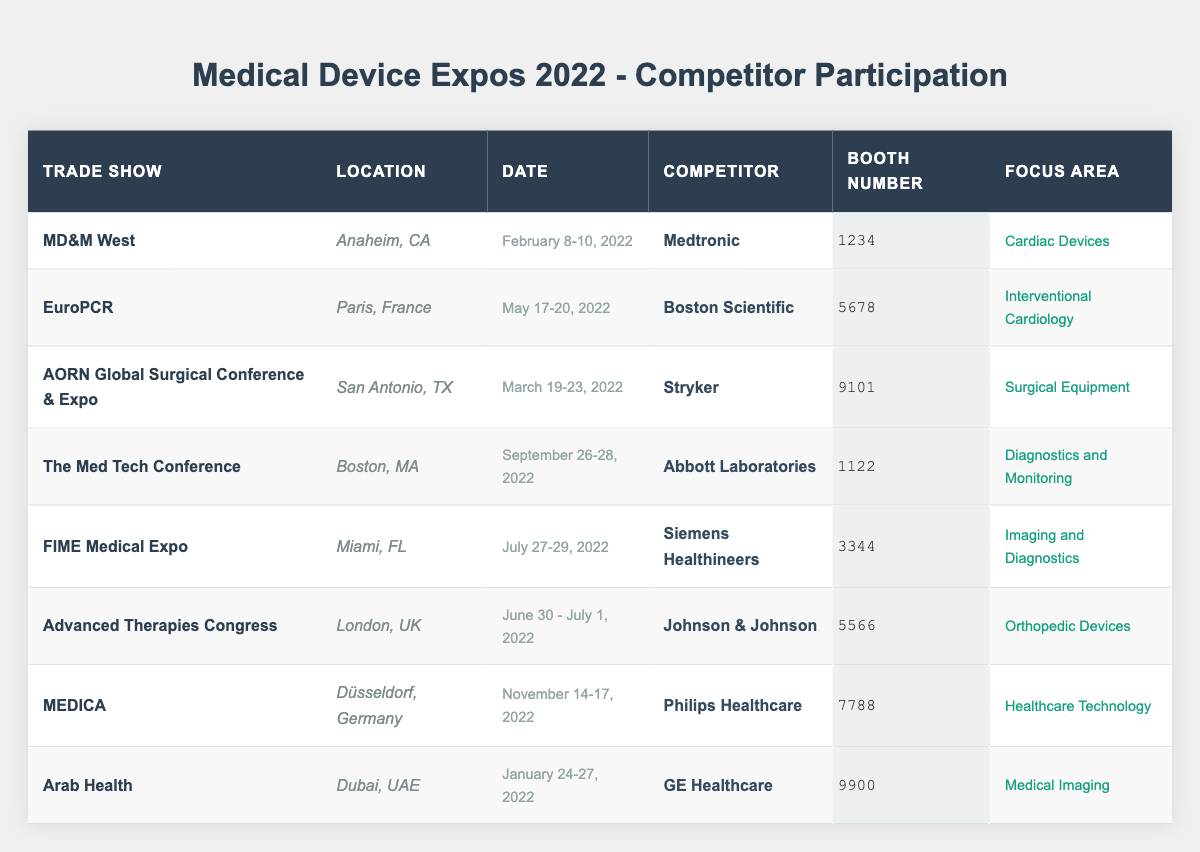What competitors participated in the MD&M West trade show? According to the table, Medtronic participated in the MD&M West trade show.
Answer: Medtronic Which trade show took place in July 2022? The table displays that the FIME Medical Expo took place on July 27-29, 2022.
Answer: FIME Medical Expo How many trade shows did GE Healthcare attend in 2022? The table indicates that GE Healthcare participated in one trade show: Arab Health.
Answer: 1 What is the focus area of Abbott Laboratories at The Med Tech Conference? According to the table, Abbott Laboratories focused on Diagnostics and Monitoring at The Med Tech Conference.
Answer: Diagnostics and Monitoring Which competitor had the booth number 5566? The table shows that Johnson & Johnson had booth number 5566 at the Advanced Therapies Congress trade show.
Answer: Johnson & Johnson What trade show had the earliest date in January 2022? Reviewing the table, the Arab Health trade show was the earliest in January 2022, taking place from January 24-27.
Answer: Arab Health How many trade shows focused on cardiac devices? From the table, only one trade show, MD&M West, focused on cardiac devices, represented by Medtronic.
Answer: 1 Did Siemens Healthineers participate in a trade show focused on diagnostics? The table indicates that Siemens Healthineers participated in FIME Medical Expo, which focused on Imaging and Diagnostics, so the answer is yes.
Answer: Yes What is the common focus area for the trade shows attended by competitors in the first half of 2022? Looking at the table, there are multiple areas of focus including Surgical Equipment, Interventional Cardiology, and Orthopedic Devices; therefore, the common focus areas are varied and not a single one.
Answer: Varied Which competitor had the latest participation in a trade show in 2022, and what was the event? By examining the table, Philips Healthcare had the latest participation at MEDICA, which occurred from November 14-17, 2022.
Answer: Philips Healthcare at MEDICA How many competitors participated in conferences related to imaging and diagnostics? The table shows that Siemens Healthineers at FIME Medical Expo is focused on Imaging and Diagnostics, indicating only one competitor focused in this area.
Answer: 1 What was the location of the EuroPCR trade show? The table indicates that EuroPCR was located in Paris, France.
Answer: Paris, France 